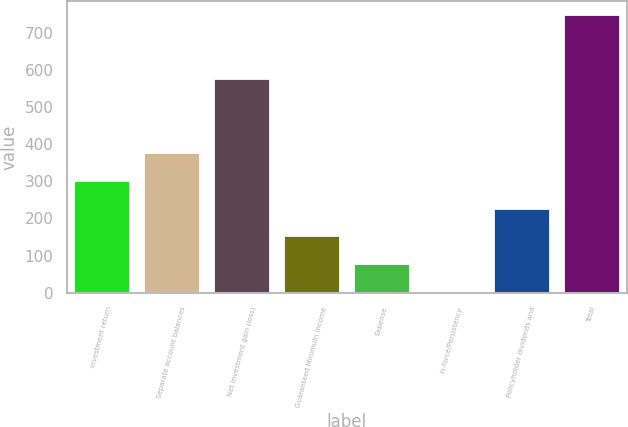Convert chart to OTSL. <chart><loc_0><loc_0><loc_500><loc_500><bar_chart><fcel>Investment return<fcel>Separate account balances<fcel>Net investment gain (loss)<fcel>Guaranteed Minimum Income<fcel>Expense<fcel>In-force/Persistency<fcel>Policyholder dividends and<fcel>Total<nl><fcel>300.8<fcel>375.5<fcel>576<fcel>151.4<fcel>76.7<fcel>2<fcel>226.1<fcel>749<nl></chart> 